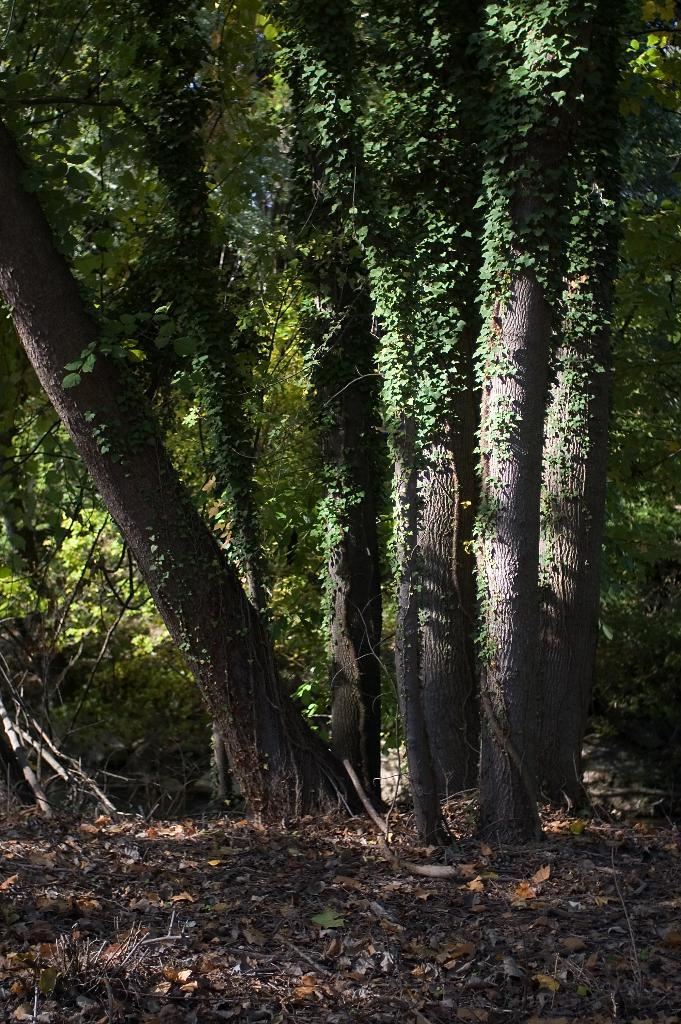What is on the ground in the image? There are dry leaves on the ground in the image. What can be seen in the background of the image? There are trees in the background of the image. What type of loaf is being crushed by the trees in the image? There is no loaf present in the image, and the trees are not crushing anything. 